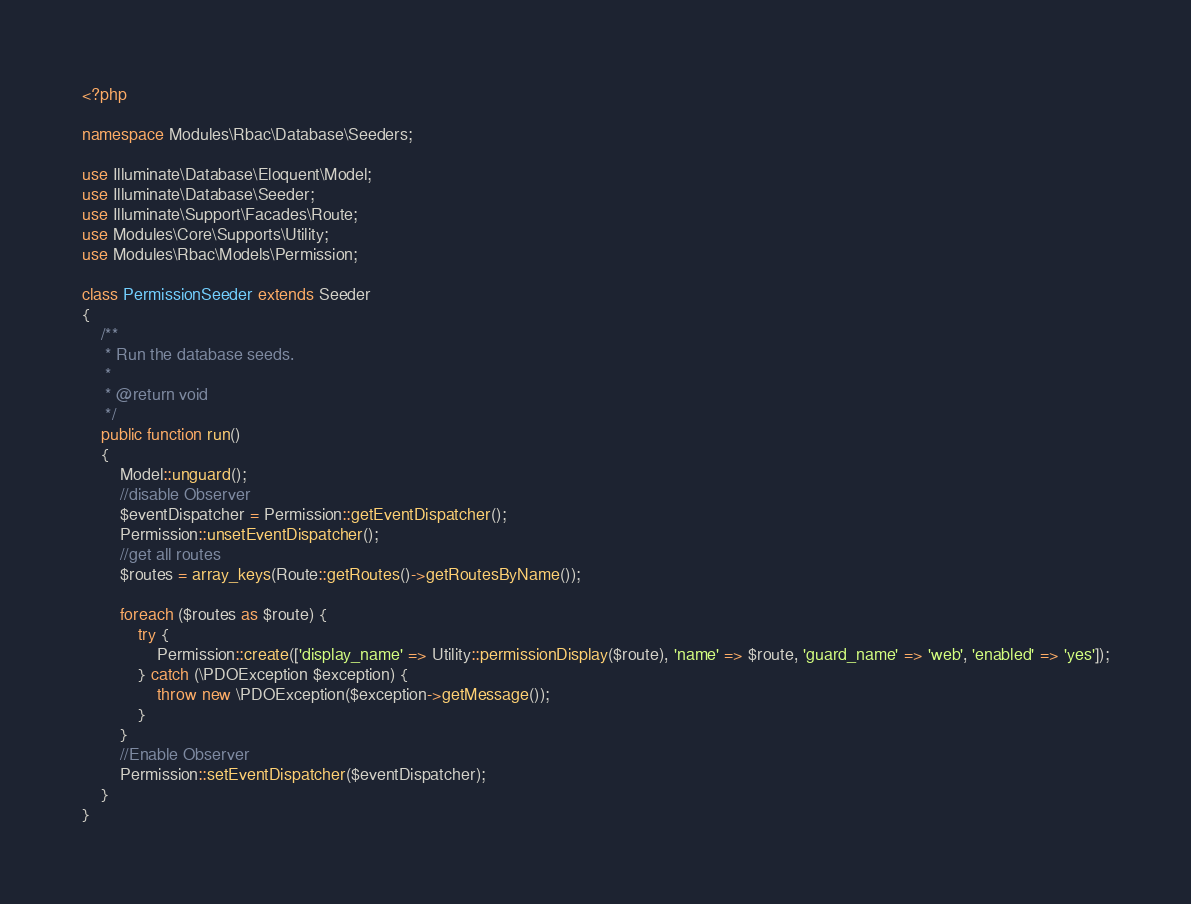<code> <loc_0><loc_0><loc_500><loc_500><_PHP_><?php

namespace Modules\Rbac\Database\Seeders;

use Illuminate\Database\Eloquent\Model;
use Illuminate\Database\Seeder;
use Illuminate\Support\Facades\Route;
use Modules\Core\Supports\Utility;
use Modules\Rbac\Models\Permission;

class PermissionSeeder extends Seeder
{
    /**
     * Run the database seeds.
     *
     * @return void
     */
    public function run()
    {
        Model::unguard();
        //disable Observer
        $eventDispatcher = Permission::getEventDispatcher();
        Permission::unsetEventDispatcher();
        //get all routes
        $routes = array_keys(Route::getRoutes()->getRoutesByName());

        foreach ($routes as $route) {
            try {
                Permission::create(['display_name' => Utility::permissionDisplay($route), 'name' => $route, 'guard_name' => 'web', 'enabled' => 'yes']);
            } catch (\PDOException $exception) {
                throw new \PDOException($exception->getMessage());
            }
        }
        //Enable Observer
        Permission::setEventDispatcher($eventDispatcher);
    }
}
</code> 